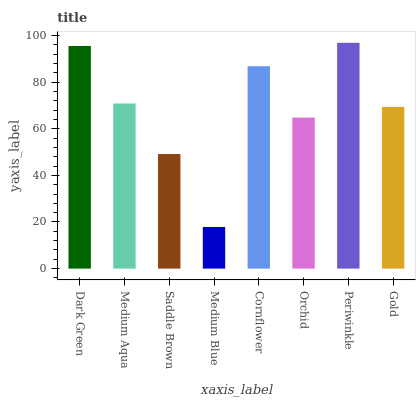Is Medium Blue the minimum?
Answer yes or no. Yes. Is Periwinkle the maximum?
Answer yes or no. Yes. Is Medium Aqua the minimum?
Answer yes or no. No. Is Medium Aqua the maximum?
Answer yes or no. No. Is Dark Green greater than Medium Aqua?
Answer yes or no. Yes. Is Medium Aqua less than Dark Green?
Answer yes or no. Yes. Is Medium Aqua greater than Dark Green?
Answer yes or no. No. Is Dark Green less than Medium Aqua?
Answer yes or no. No. Is Medium Aqua the high median?
Answer yes or no. Yes. Is Gold the low median?
Answer yes or no. Yes. Is Periwinkle the high median?
Answer yes or no. No. Is Medium Aqua the low median?
Answer yes or no. No. 